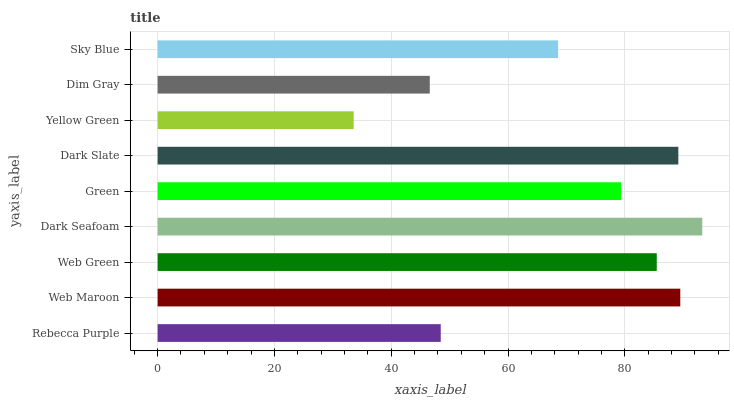Is Yellow Green the minimum?
Answer yes or no. Yes. Is Dark Seafoam the maximum?
Answer yes or no. Yes. Is Web Maroon the minimum?
Answer yes or no. No. Is Web Maroon the maximum?
Answer yes or no. No. Is Web Maroon greater than Rebecca Purple?
Answer yes or no. Yes. Is Rebecca Purple less than Web Maroon?
Answer yes or no. Yes. Is Rebecca Purple greater than Web Maroon?
Answer yes or no. No. Is Web Maroon less than Rebecca Purple?
Answer yes or no. No. Is Green the high median?
Answer yes or no. Yes. Is Green the low median?
Answer yes or no. Yes. Is Rebecca Purple the high median?
Answer yes or no. No. Is Dark Slate the low median?
Answer yes or no. No. 